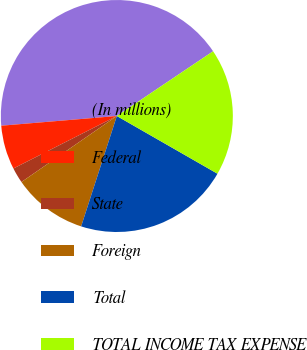Convert chart. <chart><loc_0><loc_0><loc_500><loc_500><pie_chart><fcel>(In millions)<fcel>Federal<fcel>State<fcel>Foreign<fcel>Total<fcel>TOTAL INCOME TAX EXPENSE<nl><fcel>41.91%<fcel>6.14%<fcel>2.16%<fcel>10.39%<fcel>21.69%<fcel>17.71%<nl></chart> 